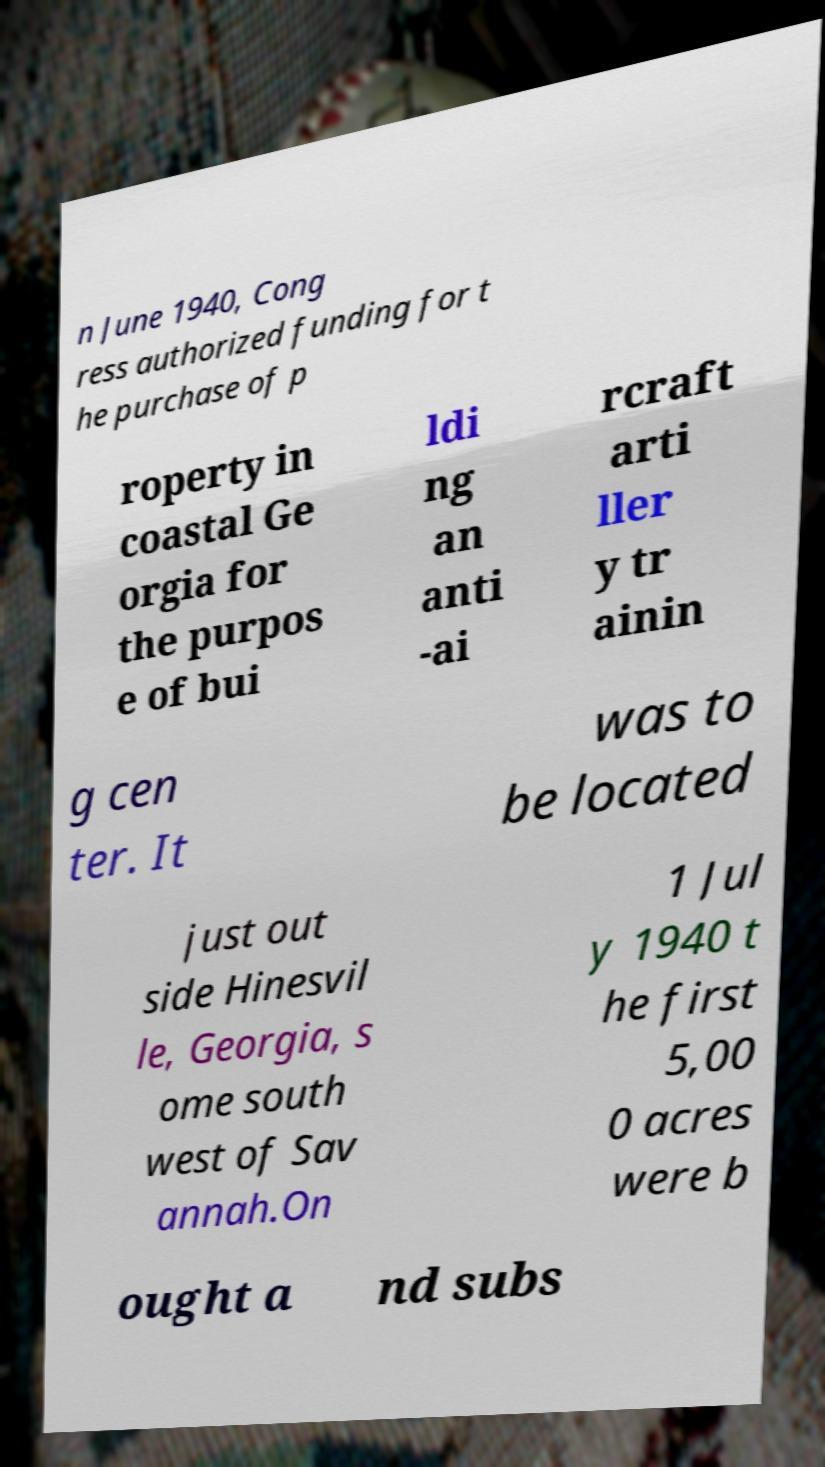There's text embedded in this image that I need extracted. Can you transcribe it verbatim? n June 1940, Cong ress authorized funding for t he purchase of p roperty in coastal Ge orgia for the purpos e of bui ldi ng an anti -ai rcraft arti ller y tr ainin g cen ter. It was to be located just out side Hinesvil le, Georgia, s ome south west of Sav annah.On 1 Jul y 1940 t he first 5,00 0 acres were b ought a nd subs 